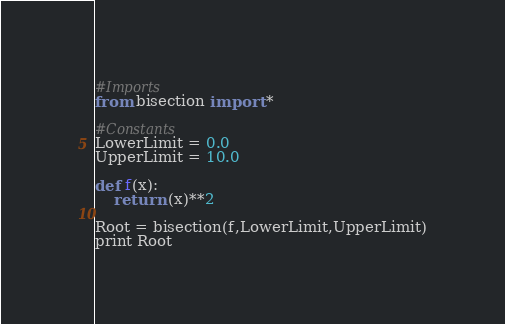Convert code to text. <code><loc_0><loc_0><loc_500><loc_500><_Python_>#Imports
from bisection import *

#Constants
LowerLimit = 0.0
UpperLimit = 10.0

def f(x):
    return (x)**2

Root = bisection(f,LowerLimit,UpperLimit)
print Root
</code> 